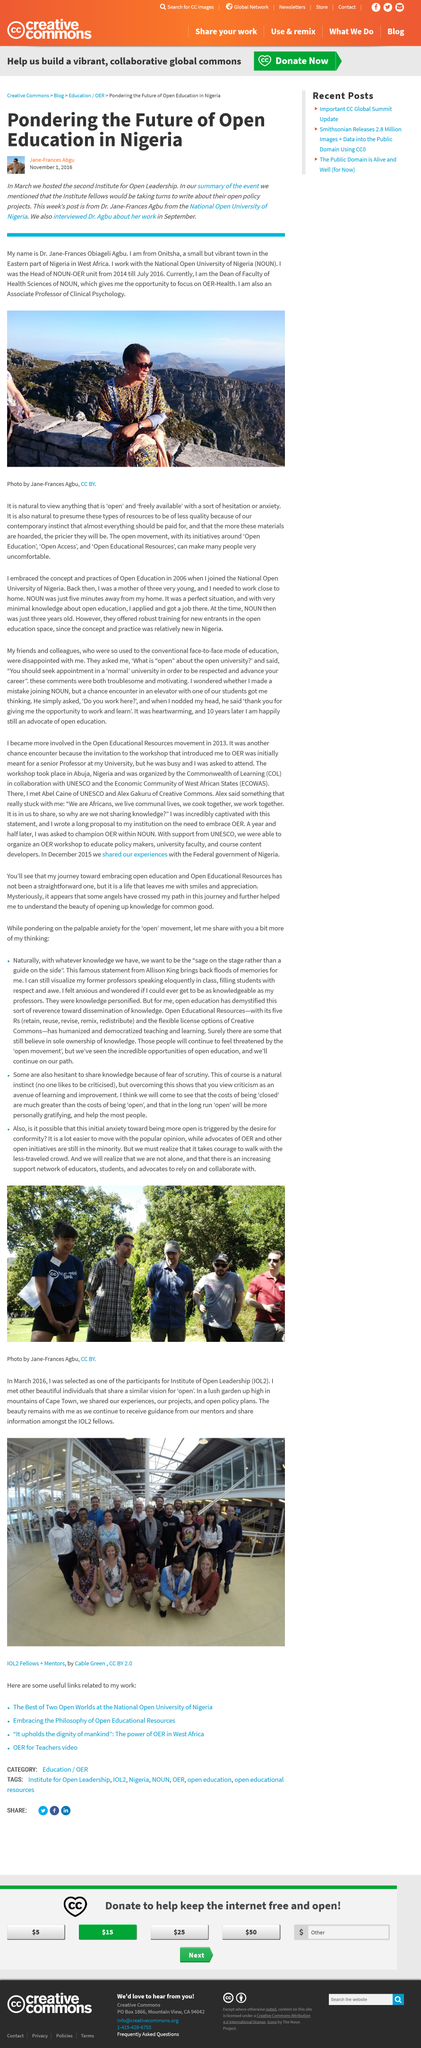Draw attention to some important aspects in this diagram. Onitsha is the place of origin of Dr Agbu. Dr. Agbu is an Associate Professor of Clinical Psychology. The article about Open Education in Nigeria was published on November 1, 2016. 